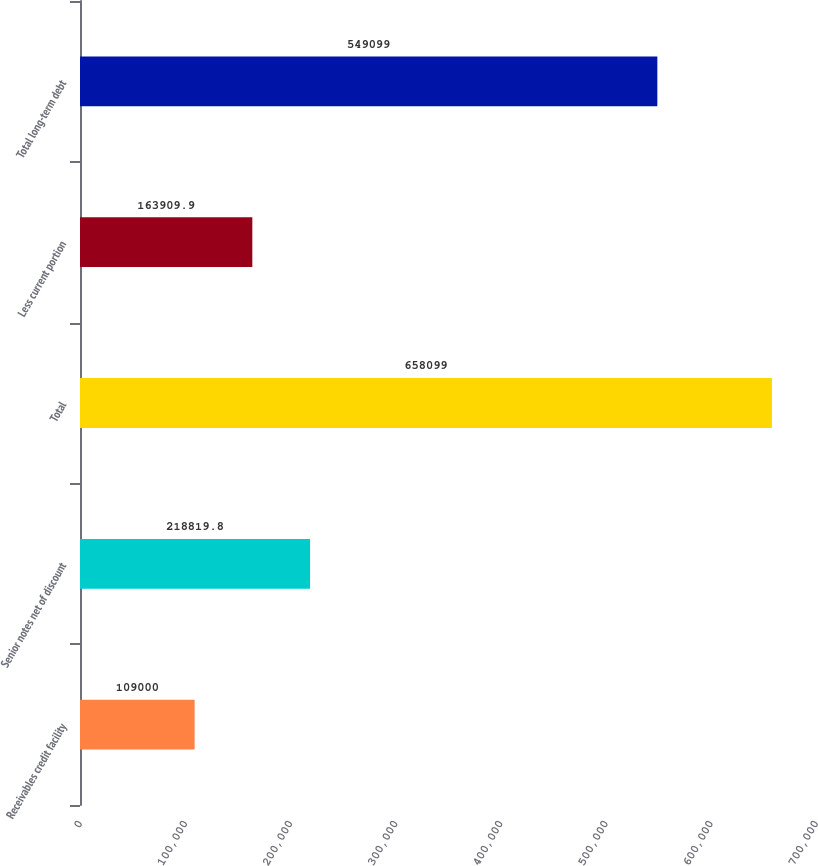<chart> <loc_0><loc_0><loc_500><loc_500><bar_chart><fcel>Receivables credit facility<fcel>Senior notes net of discount<fcel>Total<fcel>Less current portion<fcel>Total long-term debt<nl><fcel>109000<fcel>218820<fcel>658099<fcel>163910<fcel>549099<nl></chart> 